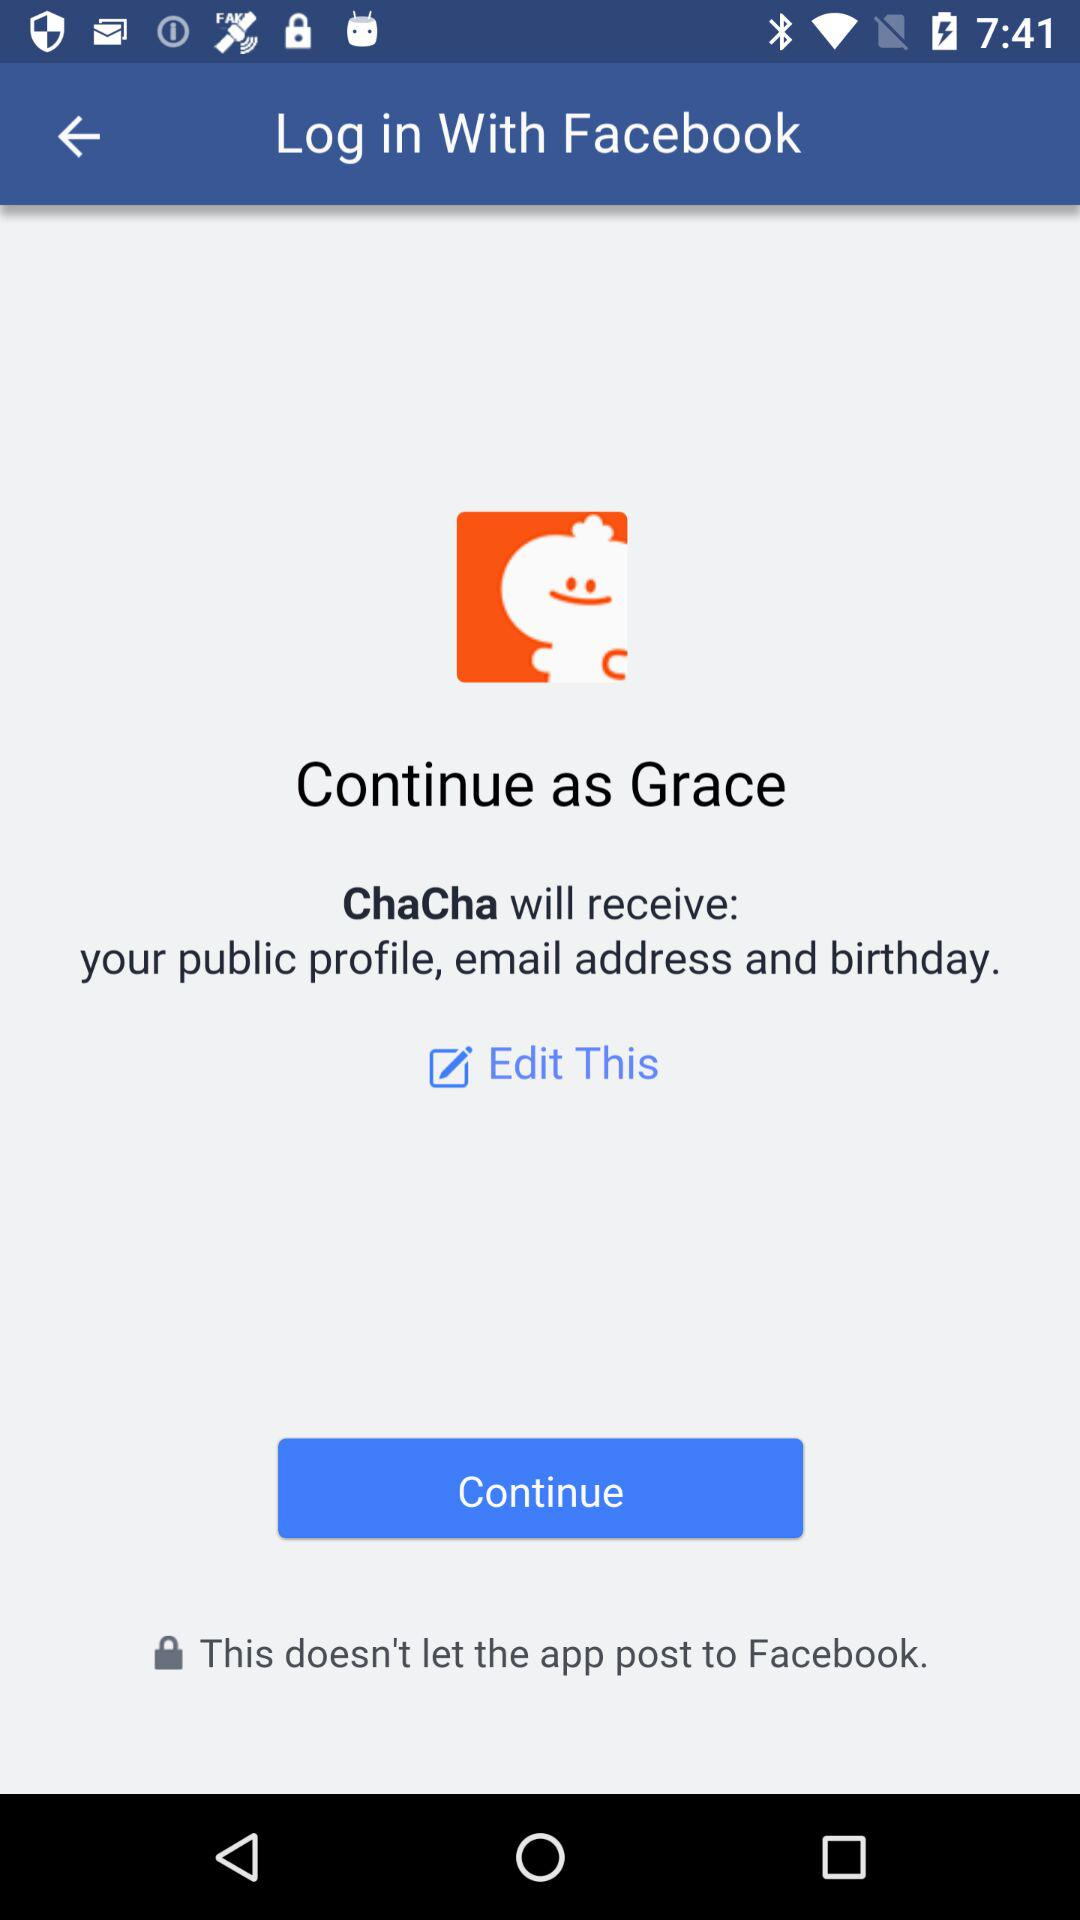Through what account can logging in be done? Logging in can be done through "Facebook" account. 